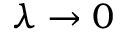Convert formula to latex. <formula><loc_0><loc_0><loc_500><loc_500>\lambda \to 0</formula> 